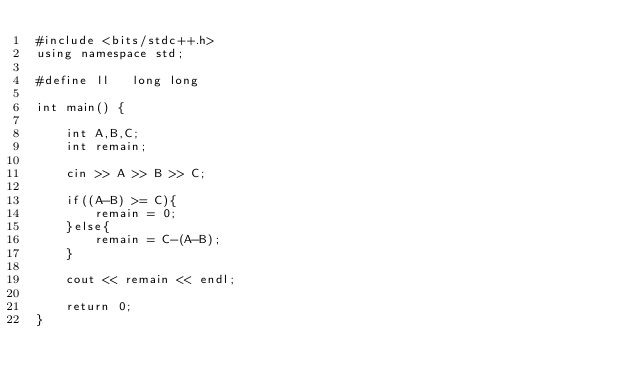Convert code to text. <code><loc_0><loc_0><loc_500><loc_500><_C++_>#include <bits/stdc++.h>
using namespace std;

#define ll   long long

int main() {

    int A,B,C;
    int remain;

    cin >> A >> B >> C;

    if((A-B) >= C){
        remain = 0;
    }else{
        remain = C-(A-B);
    }

    cout << remain << endl;

    return 0;
}</code> 